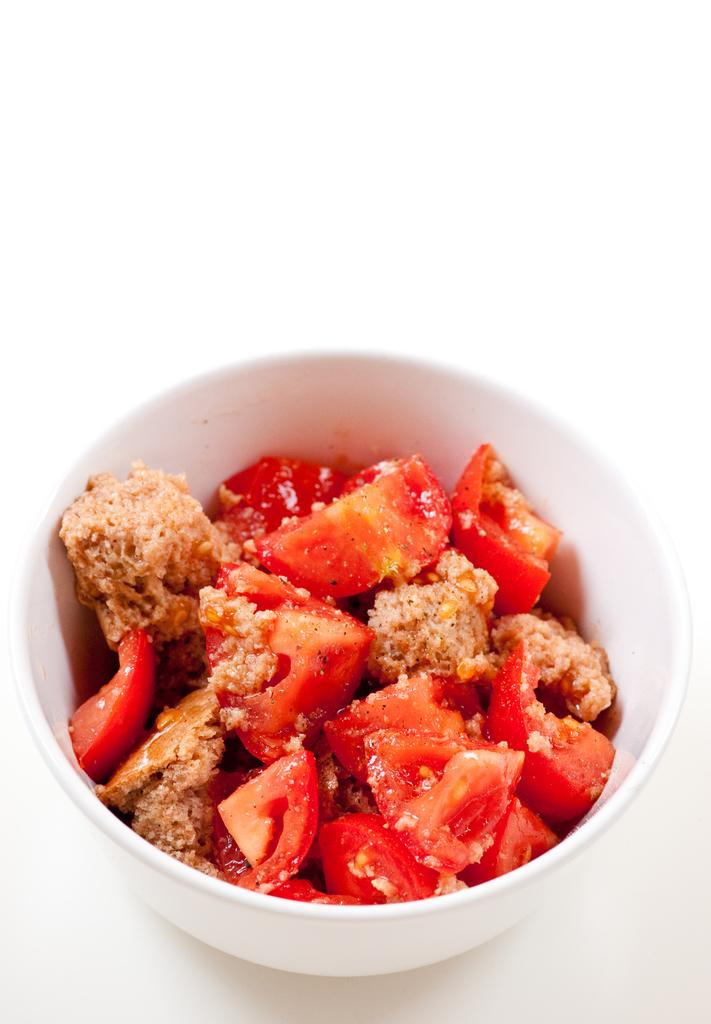What is in the bowl that is visible in the image? The bowl contains food. Can you describe the contents of the bowl? Unfortunately, the specific contents of the bowl cannot be determined from the provided facts. Where is the bowl located in the image? The bowl is placed on a surface. How many pizzas are being held by the women in the image? There are no women or pizzas present in the image. Is there a lamp visible in the image? There is no mention of a lamp in the provided facts, so it cannot be determined if one is present in the image. 